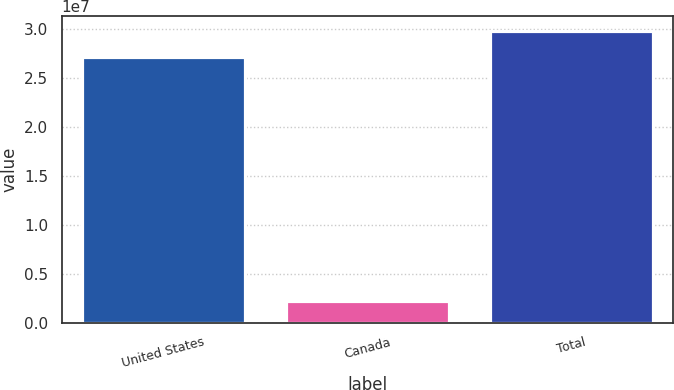Convert chart to OTSL. <chart><loc_0><loc_0><loc_500><loc_500><bar_chart><fcel>United States<fcel>Canada<fcel>Total<nl><fcel>2.71444e+07<fcel>2.19105e+06<fcel>2.98588e+07<nl></chart> 